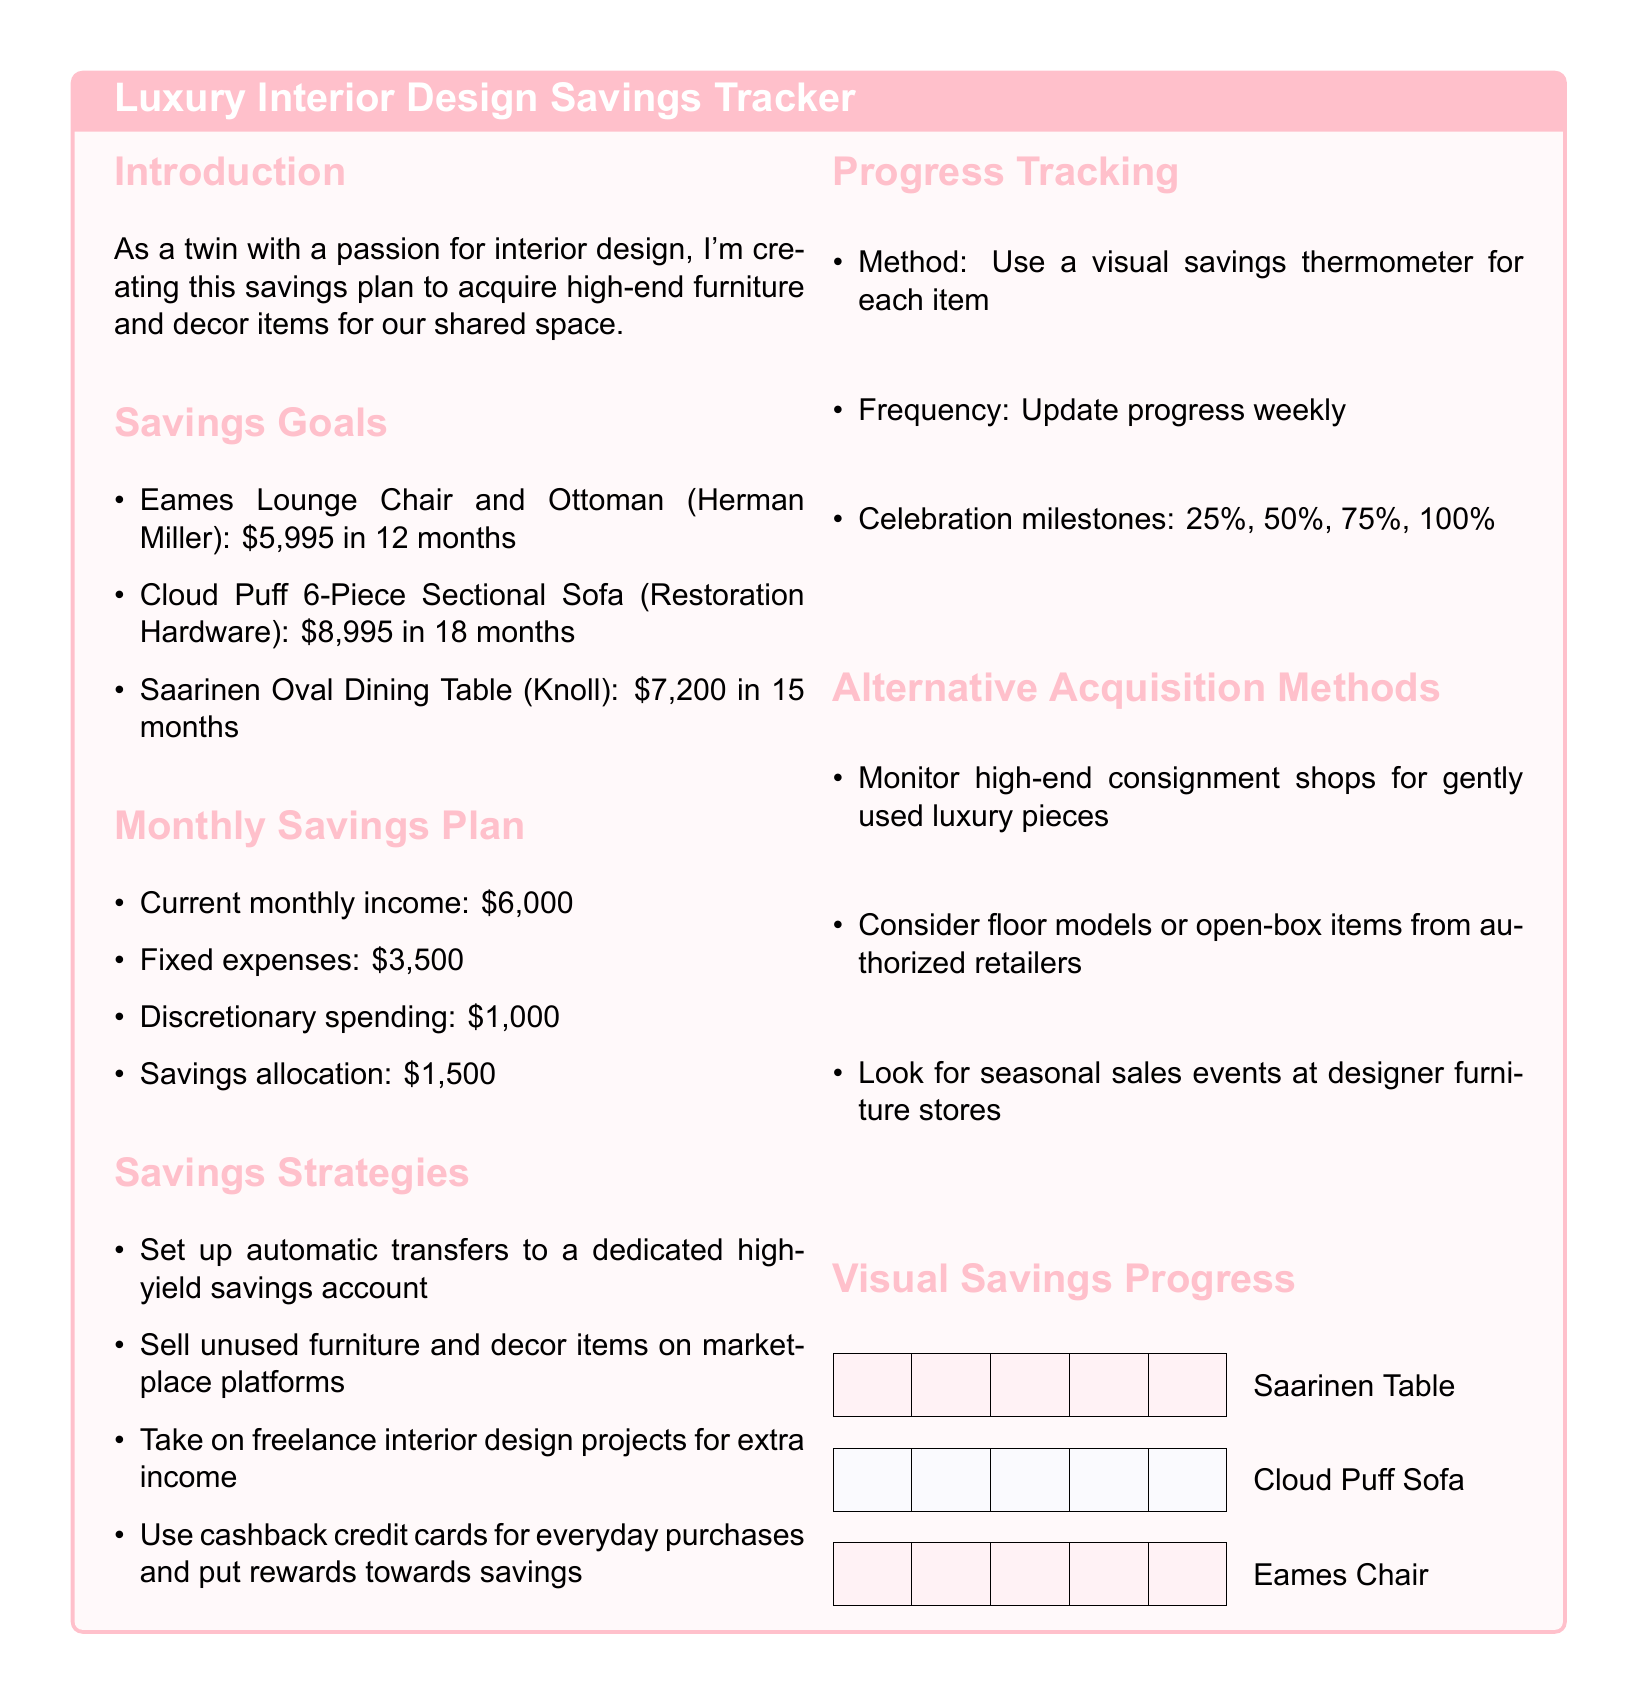what is the total cost of the Eames Lounge Chair and Ottoman? The cost of the Eames Lounge Chair and Ottoman is explicitly stated in the document.
Answer: $5,995 how many months to save for the Cloud Puff Sectional Sofa? The timeline for saving for the Cloud Puff Sectional Sofa is provided in the savings goals section of the document.
Answer: 18 months what is the monthly discretionary spending amount? The monthly discretionary spending amount is mentioned in the monthly savings plan section.
Answer: $1,000 how much is allocated for savings each month? The savings allocation is detailed in the monthly savings plan section of the document.
Answer: $1,500 which furniture item has the highest price? The highest priced item among the listed savings goals can be found in the savings goals section.
Answer: Cloud Puff 6-Piece Sectional Sofa what percentage milestones are set for celebrating progress? The celebration milestones percentage is specified in the progress tracking section of the document.
Answer: 25%, 50%, 75%, 100% what is the method used for progress tracking? The method for tracking savings progress is described in the progress tracking section.
Answer: Visual savings thermometer name one strategy for increasing savings. The savings strategies section lists multiple tactics to increase savings.
Answer: Sell unused furniture which high-end furniture piece requires saving for 15 months? The timeframe for saving for this specific piece is stated in the savings goals section.
Answer: Saarinen Oval Dining Table 